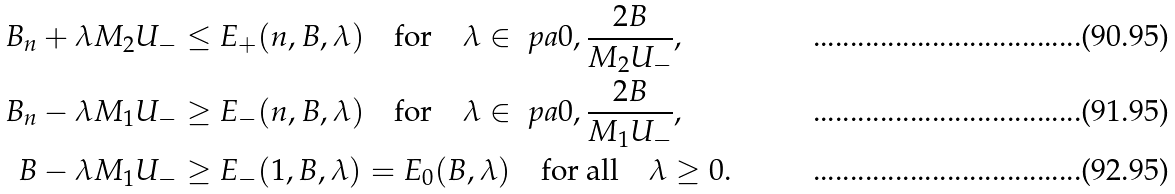<formula> <loc_0><loc_0><loc_500><loc_500>B _ { n } + \lambda M _ { 2 } U _ { - } & \leq E _ { + } ( n , B , \lambda ) \quad \text {for} \quad \lambda \in \ p a { 0 , \frac { 2 B } { M _ { 2 } U _ { - } } } , \\ B _ { n } - \lambda M _ { 1 } U _ { - } & \geq E _ { - } ( n , B , \lambda ) \quad \text {for} \quad \lambda \in \ p a { 0 , \frac { 2 B } { M _ { 1 } U _ { - } } } , \\ B - \lambda M _ { 1 } U _ { - } & \geq E _ { - } ( 1 , B , \lambda ) = E _ { 0 } ( B , \lambda ) \quad \text {for all} \quad \lambda \geq 0 .</formula> 